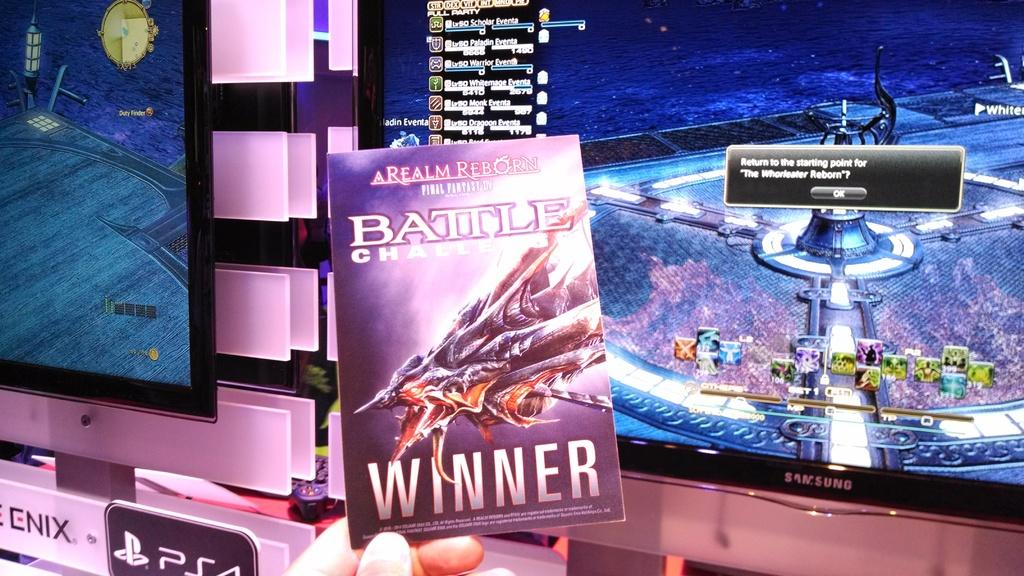<image>
Relay a brief, clear account of the picture shown. A person holding up Realm Reborn Battle video game. 